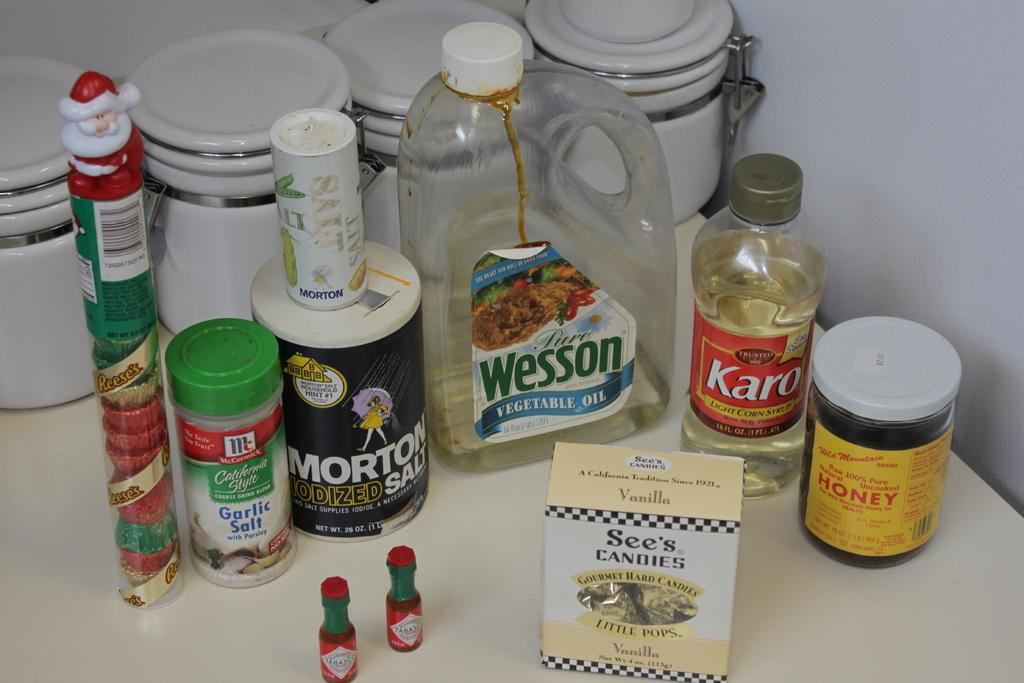<image>
Summarize the visual content of the image. A box of See's Candies in on a counter near salt, honey, Karo, and oil. 